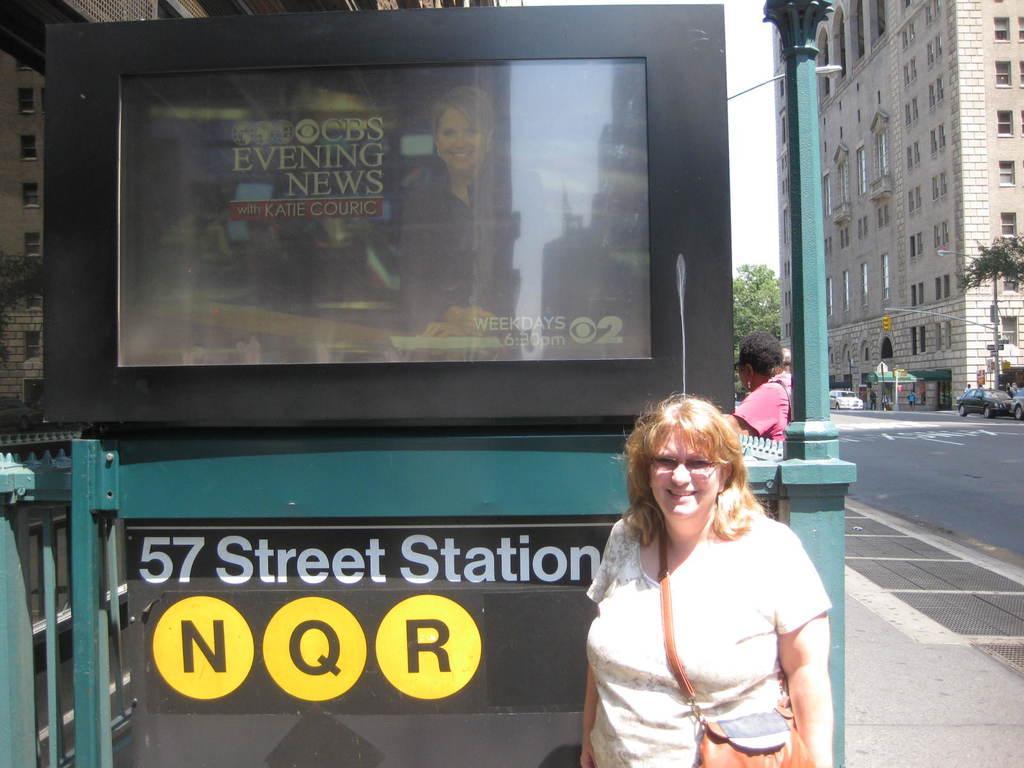Describe this image in one or two sentences. In this image I can see a woman visible at the bottom and backside of the woman I can see screen and hoarding board , on hoarding board I can see a text and image of person and on the right side I can see building ,trees and road and persons and the sky and street light poles and vehicles and on the left side I can see buildings 